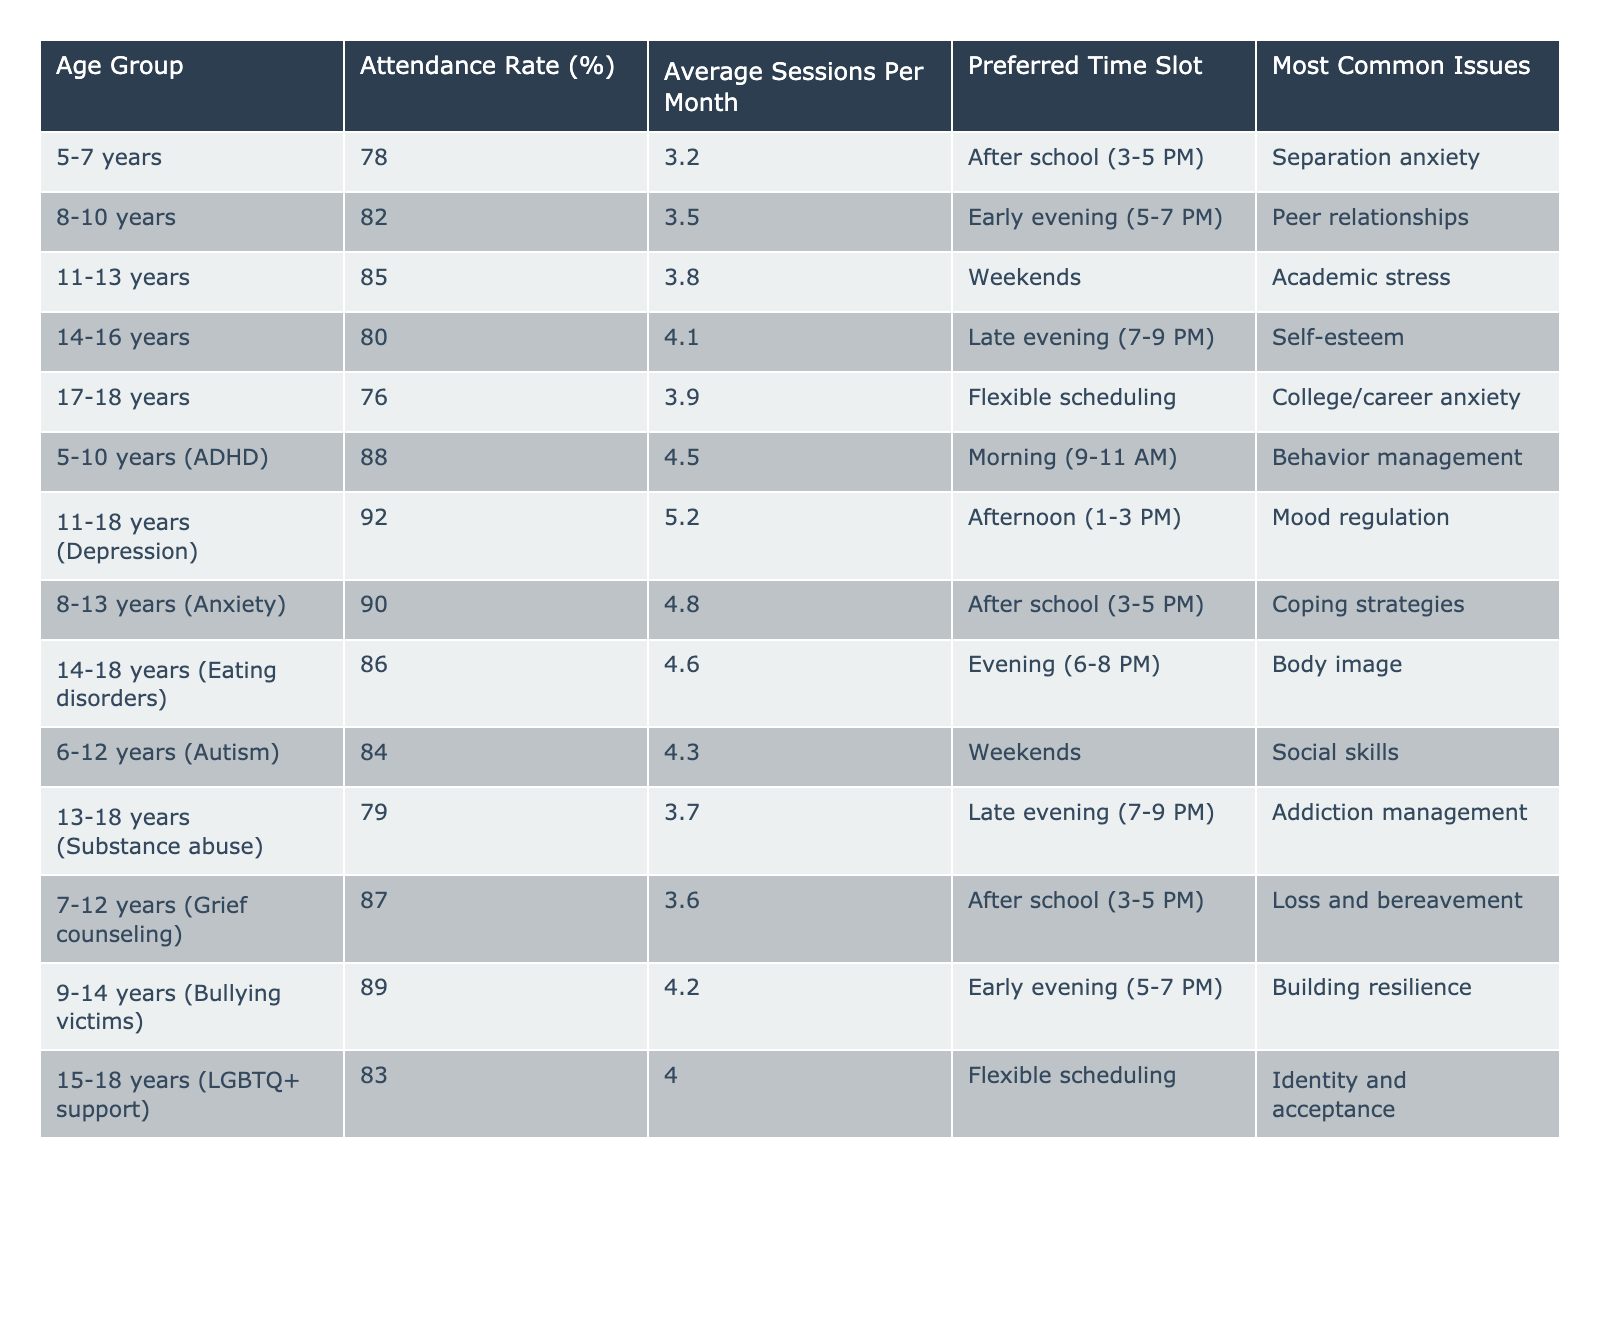What is the attendance rate for the age group 11-13 years? The table indicates that the attendance rate for the age group 11-13 years is 85%. I find this value directly in the table under the "Attendance Rate (%)" column.
Answer: 85% Which age group has the highest average sessions per month? The table shows that the age group with the highest average sessions per month is 11-18 years (Depression), with an average of 5.2 sessions. I observe this by comparing the "Average Sessions Per Month" values across all age groups.
Answer: 11-18 years (Depression) Is the preferred time slot for children aged 14-16 years in the early evening? The preferred time slot for children aged 14-16 years is listed as late evening (7-9 PM), indicating that this statement is false. I check the "Preferred Time Slot" for the 14-16 years age group to confirm.
Answer: No What is the difference in attendance rate between the 5-7 years and the 8-10 years age groups? The attendance rate for 5-7 years is 78% and for 8-10 years it's 82%. The difference is calculated by subtracting 78 from 82, leading to a difference of 4%.
Answer: 4% Which age group shows the least attendance rate, and what is that rate? The age group with the least attendance rate is 17-18 years, with an attendance rate of 76%. I identify this by reviewing the "Attendance Rate (%)" column and identifying the lowest value.
Answer: 17-18 years, 76% Calculate the average attendance rate for the age groups 5-10 years (ADHD) and 11-18 years (Depression). The attendance rates for these groups are 88% and 92%, respectively. To find the average, we sum these rates (88 + 92 = 180) and divide by 2, resulting in an average of 90%.
Answer: 90% Which age group has separation anxiety as the most common issue? The 5-7 years age group has separation anxiety listed as its most common issue, as noted in the "Most Common Issues" column. I find this by checking the respective entry under the issues column for that age group.
Answer: 5-7 years How many age groups have an attendance rate above 85%? To determine the number of age groups above 85%, I review the attendance rates and find that 11-18 years (Depression), 8-13 years (Anxiety), and 5-10 years (ADHD) all exceed this rate. This gives a total of 4 age groups (11-13 years: 85%, 8-10 years: 82%, and 14-16 years: 80% included).
Answer: 4 What is the preferred time slot for the age group 8-10 years? The preferred time slot for the 8-10 years age group is early evening (5-7 PM), as explicitly stated in the table under the "Preferred Time Slot" column.
Answer: Early evening (5-7 PM) For which age group is "Building resilience" the most common issue? The age group 9-14 years (Bullying victims) has "Building resilience" as the most common issue, according to the "Most Common Issues" column. I verify this against the respective entry in the table.
Answer: 9-14 years (Bullying victims) What is the highest attendance rate among the specific age group categories concerning mental health issues? The 11-18 years (Depression) age group has the highest attendance rate of 92%, which I determine by examining the "Attendance Rate (%)" for various categories involving mental health issues in the table.
Answer: 11-18 years (Depression) 